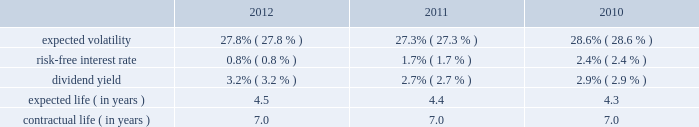Republic services , inc .
Notes to consolidated financial statements 2014 ( continued ) in december 2008 , the board of directors amended and restated the republic services , inc .
2006 incentive stock plan ( formerly known as the allied waste industries , inc .
2006 incentive stock plan ( the 2006 plan ) ) .
Allied 2019s stockholders approved the 2006 plan in may 2006 .
The 2006 plan was amended and restated in december 2008 to reflect that republic services , inc .
Is the new sponsor of the plan , that any references to shares of common stock is to shares of common stock of republic services , inc. , and to adjust outstanding awards and the number of shares available under the plan to reflect the acquisition .
The 2006 plan , as amended and restated , provides for the grant of non-qualified stock options , incentive stock options , shares of restricted stock , shares of phantom stock , stock bonuses , restricted stock units , stock appreciation rights , performance awards , dividend equivalents , cash awards , or other stock-based awards .
Awards granted under the 2006 plan prior to december 5 , 2008 became fully vested and nonforfeitable upon the closing of the acquisition .
Awards may be granted under the 2006 plan , as amended and restated , after december 5 , 2008 only to employees and consultants of allied waste industries , inc .
And its subsidiaries who were not employed by republic services , inc .
Prior to such date .
At december 31 , 2012 , there were approximately 15.5 million shares of common stock reserved for future grants under the 2006 plan .
Stock options we use a binomial option-pricing model to value our stock option grants .
We recognize compensation expense on a straight-line basis over the requisite service period for each separately vesting portion of the award , or to the employee 2019s retirement eligible date , if earlier .
Expected volatility is based on the weighted average of the most recent one year volatility and a historical rolling average volatility of our stock over the expected life of the option .
The risk-free interest rate is based on federal reserve rates in effect for bonds with maturity dates equal to the expected term of the option .
We use historical data to estimate future option exercises , forfeitures ( at 3.0% ( 3.0 % ) for each of the period presented ) and expected life of the options .
When appropriate , separate groups of employees that have similar historical exercise behavior are considered separately for valuation purposes .
The weighted-average estimated fair values of stock options granted during the years ended december 31 , 2012 , 2011 and 2010 were $ 4.77 , $ 5.35 and $ 5.28 per option , respectively , which were calculated using the following weighted-average assumptions: .

What was the percent of the change in the dividend yield from 2011 to 2012? 
Rationale: the change in the percent is the change from the early period to the most recent divide by the early period
Computations: ((3.2 - 2.7) / 2.7)
Answer: 0.18519. 